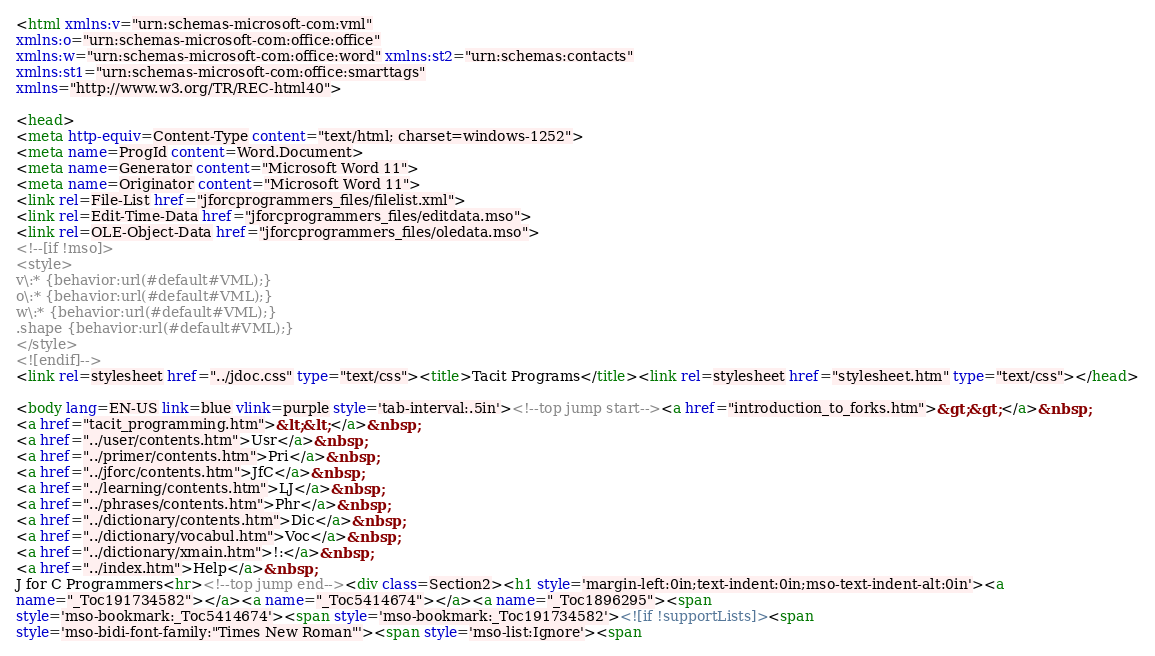<code> <loc_0><loc_0><loc_500><loc_500><_HTML_><html xmlns:v="urn:schemas-microsoft-com:vml"
xmlns:o="urn:schemas-microsoft-com:office:office"
xmlns:w="urn:schemas-microsoft-com:office:word" xmlns:st2="urn:schemas:contacts"
xmlns:st1="urn:schemas-microsoft-com:office:smarttags"
xmlns="http://www.w3.org/TR/REC-html40">

<head>
<meta http-equiv=Content-Type content="text/html; charset=windows-1252">
<meta name=ProgId content=Word.Document>
<meta name=Generator content="Microsoft Word 11">
<meta name=Originator content="Microsoft Word 11">
<link rel=File-List href="jforcprogrammers_files/filelist.xml">
<link rel=Edit-Time-Data href="jforcprogrammers_files/editdata.mso">
<link rel=OLE-Object-Data href="jforcprogrammers_files/oledata.mso">
<!--[if !mso]>
<style>
v\:* {behavior:url(#default#VML);}
o\:* {behavior:url(#default#VML);}
w\:* {behavior:url(#default#VML);}
.shape {behavior:url(#default#VML);}
</style>
<![endif]-->
<link rel=stylesheet href="../jdoc.css" type="text/css"><title>Tacit Programs</title><link rel=stylesheet href="stylesheet.htm" type="text/css"></head>

<body lang=EN-US link=blue vlink=purple style='tab-interval:.5in'><!--top jump start--><a href="introduction_to_forks.htm">&gt;&gt;</a>&nbsp;
<a href="tacit_programming.htm">&lt;&lt;</a>&nbsp;
<a href="../user/contents.htm">Usr</a>&nbsp;
<a href="../primer/contents.htm">Pri</a>&nbsp;
<a href="../jforc/contents.htm">JfC</a>&nbsp;
<a href="../learning/contents.htm">LJ</a>&nbsp;
<a href="../phrases/contents.htm">Phr</a>&nbsp;
<a href="../dictionary/contents.htm">Dic</a>&nbsp;
<a href="../dictionary/vocabul.htm">Voc</a>&nbsp;
<a href="../dictionary/xmain.htm">!:</a>&nbsp;
<a href="../index.htm">Help</a>&nbsp;
J for C Programmers<hr><!--top jump end--><div class=Section2><h1 style='margin-left:0in;text-indent:0in;mso-text-indent-alt:0in'><a
name="_Toc191734582"></a><a name="_Toc5414674"></a><a name="_Toc1896295"><span
style='mso-bookmark:_Toc5414674'><span style='mso-bookmark:_Toc191734582'><![if !supportLists]><span
style='mso-bidi-font-family:"Times New Roman"'><span style='mso-list:Ignore'><span</code> 